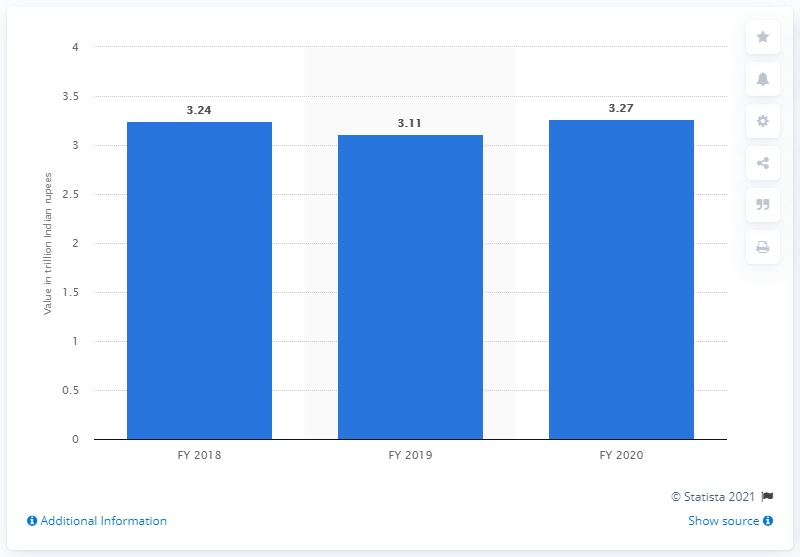Mention a couple of crucial points in this snapshot. The value of Syndicate Bank's assets in the previous fiscal year was 3.11.. 